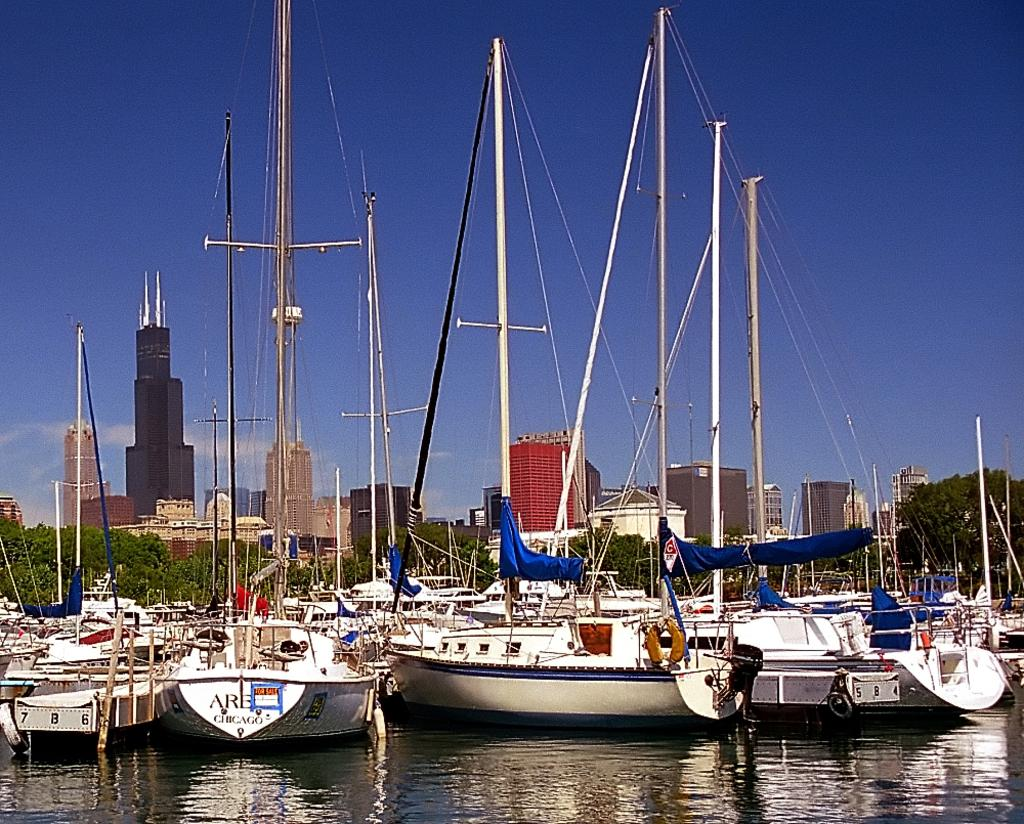<image>
Offer a succinct explanation of the picture presented. Boats sit in a marina and one with the word Chicago on the back also has a for sale sign on it. 